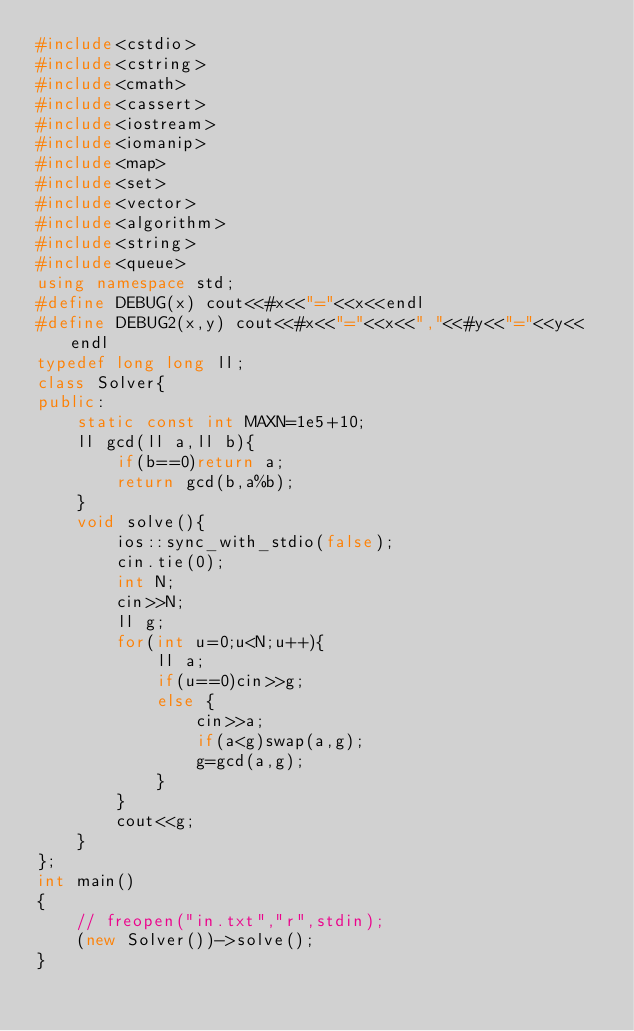<code> <loc_0><loc_0><loc_500><loc_500><_C++_>#include<cstdio>
#include<cstring>
#include<cmath>
#include<cassert>
#include<iostream>
#include<iomanip>
#include<map>
#include<set>
#include<vector>
#include<algorithm>
#include<string>
#include<queue>
using namespace std;
#define DEBUG(x) cout<<#x<<"="<<x<<endl
#define DEBUG2(x,y) cout<<#x<<"="<<x<<","<<#y<<"="<<y<<endl
typedef long long ll;
class Solver{
public:
    static const int MAXN=1e5+10;
    ll gcd(ll a,ll b){
        if(b==0)return a;
        return gcd(b,a%b);
    }
    void solve(){
        ios::sync_with_stdio(false);
        cin.tie(0);
        int N;
        cin>>N;
        ll g;
        for(int u=0;u<N;u++){
            ll a;
            if(u==0)cin>>g;
            else {
                cin>>a;
                if(a<g)swap(a,g);
                g=gcd(a,g);
            }
        }
        cout<<g;
    }
};
int main()
{
    // freopen("in.txt","r",stdin);
    (new Solver())->solve();
}</code> 